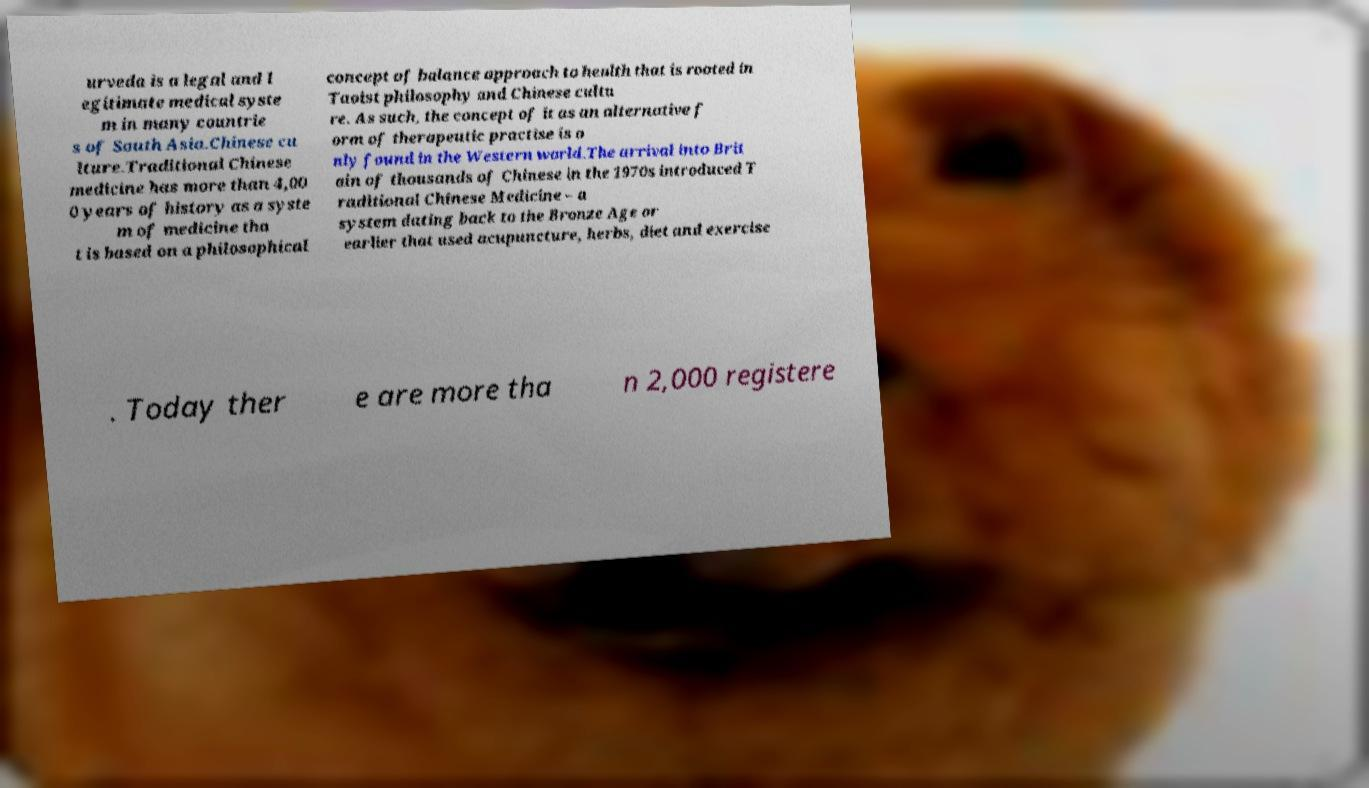Could you assist in decoding the text presented in this image and type it out clearly? urveda is a legal and l egitimate medical syste m in many countrie s of South Asia.Chinese cu lture.Traditional Chinese medicine has more than 4,00 0 years of history as a syste m of medicine tha t is based on a philosophical concept of balance approach to health that is rooted in Taoist philosophy and Chinese cultu re. As such, the concept of it as an alternative f orm of therapeutic practise is o nly found in the Western world.The arrival into Brit ain of thousands of Chinese in the 1970s introduced T raditional Chinese Medicine – a system dating back to the Bronze Age or earlier that used acupuncture, herbs, diet and exercise . Today ther e are more tha n 2,000 registere 